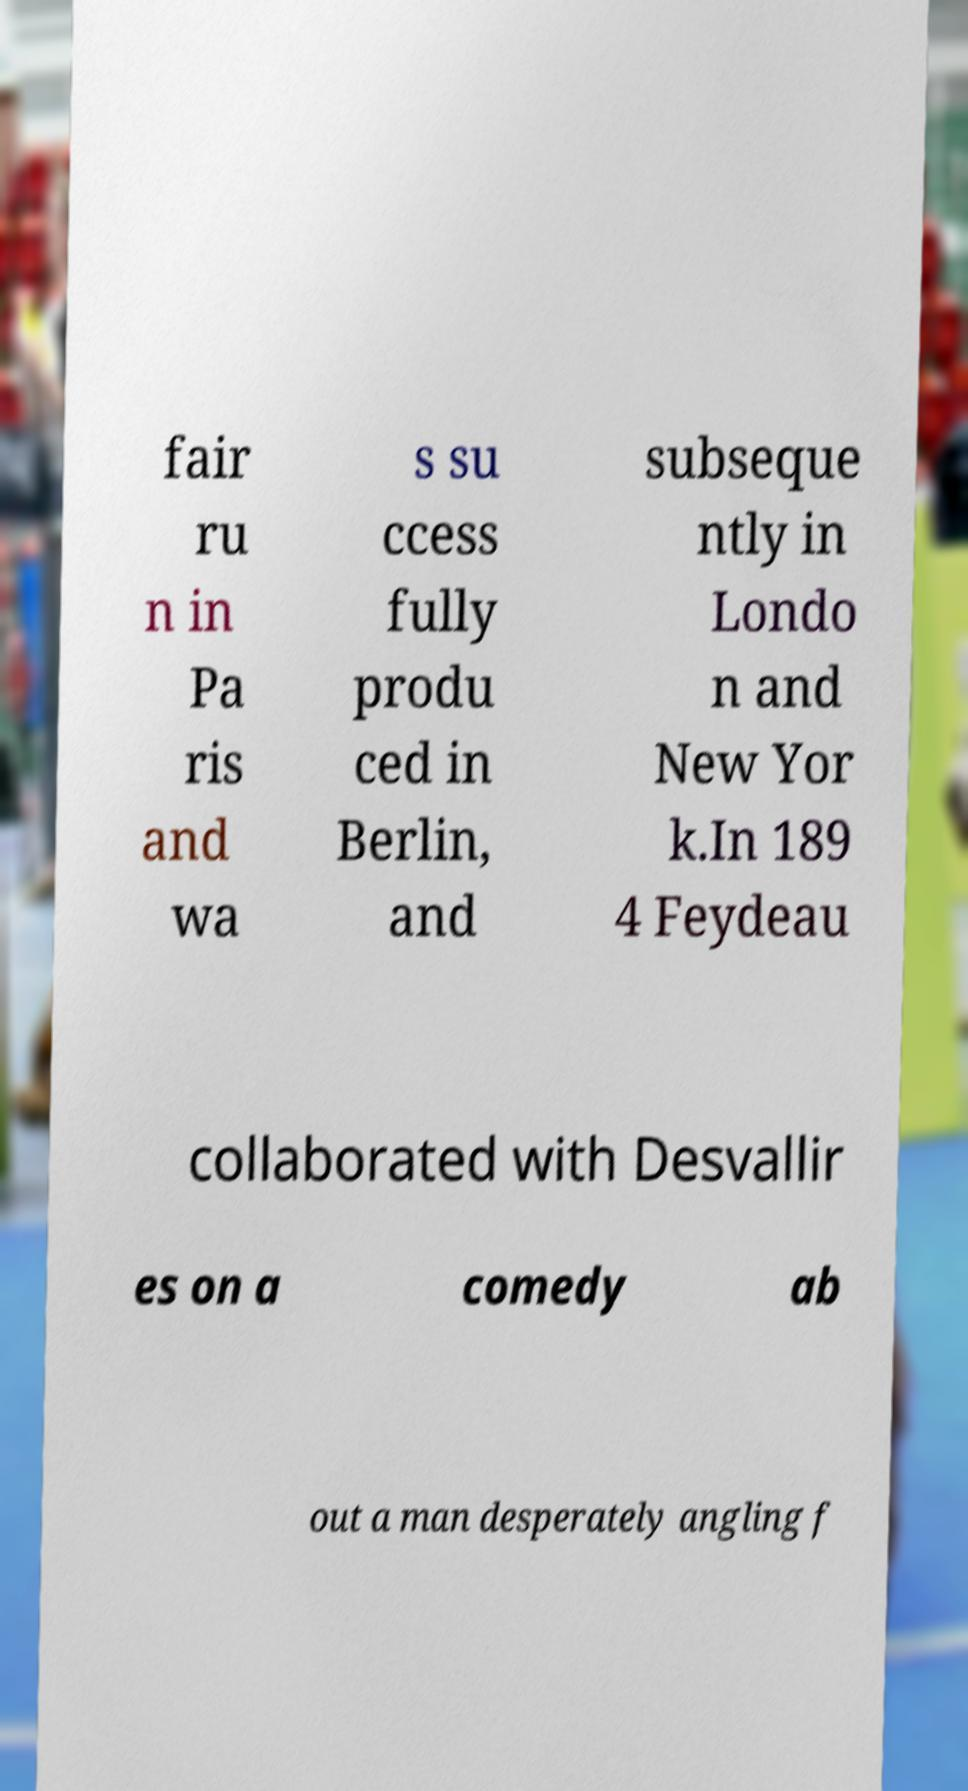There's text embedded in this image that I need extracted. Can you transcribe it verbatim? fair ru n in Pa ris and wa s su ccess fully produ ced in Berlin, and subseque ntly in Londo n and New Yor k.In 189 4 Feydeau collaborated with Desvallir es on a comedy ab out a man desperately angling f 